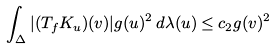<formula> <loc_0><loc_0><loc_500><loc_500>\int _ { \Delta } | ( T _ { f } K _ { u } ) ( v ) | g ( u ) ^ { 2 } \, d \lambda ( u ) \leq c _ { 2 } g ( v ) ^ { 2 }</formula> 